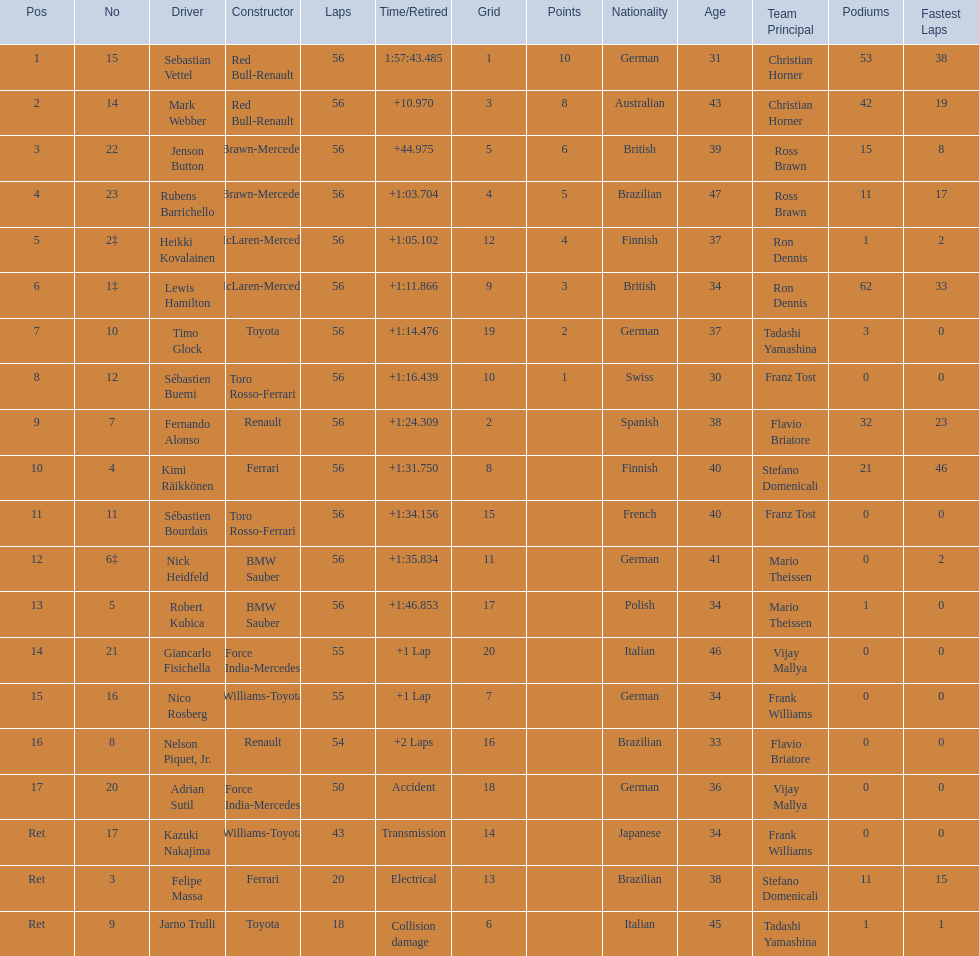Which driver is the only driver who retired because of collision damage? Jarno Trulli. 